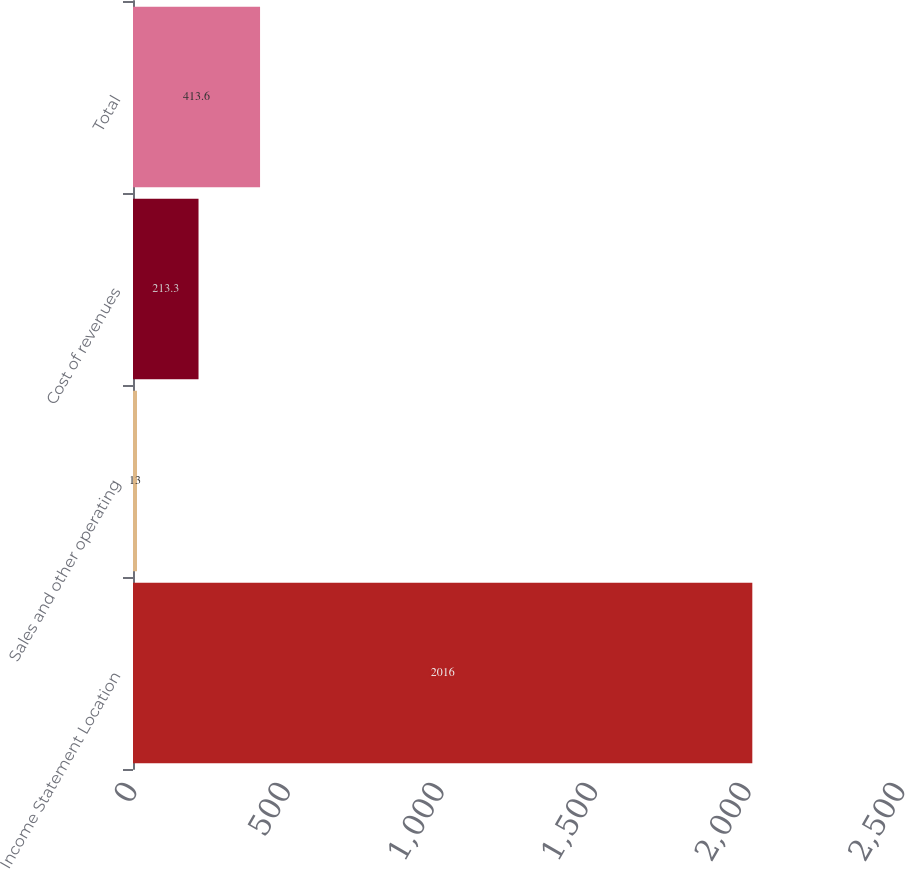Convert chart. <chart><loc_0><loc_0><loc_500><loc_500><bar_chart><fcel>Income Statement Location<fcel>Sales and other operating<fcel>Cost of revenues<fcel>Total<nl><fcel>2016<fcel>13<fcel>213.3<fcel>413.6<nl></chart> 